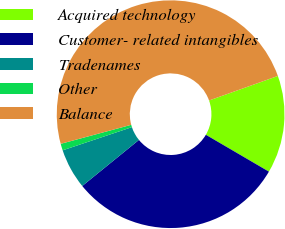<chart> <loc_0><loc_0><loc_500><loc_500><pie_chart><fcel>Acquired technology<fcel>Customer- related intangibles<fcel>Tradenames<fcel>Other<fcel>Balance<nl><fcel>13.87%<fcel>30.72%<fcel>5.72%<fcel>0.95%<fcel>48.74%<nl></chart> 